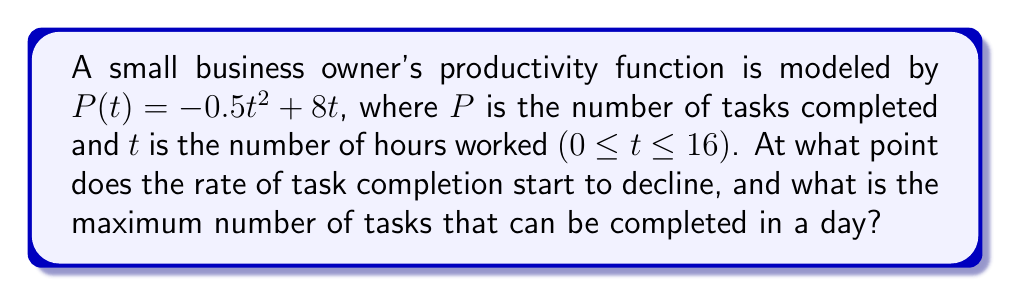Can you solve this math problem? 1. To find when the rate of task completion starts to decline, we need to find the maximum point of the productivity function. This occurs when the derivative of $P(t)$ equals zero.

2. Find the derivative of $P(t)$:
   $P'(t) = \frac{d}{dt}(-0.5t^2 + 8t) = -t + 8$

3. Set $P'(t) = 0$ and solve for $t$:
   $-t + 8 = 0$
   $t = 8$

4. This means the rate of task completion starts to decline after 8 hours of work.

5. To find the maximum number of tasks completed, substitute $t = 8$ into the original function:
   $P(8) = -0.5(8)^2 + 8(8) = -32 + 64 = 32$

Therefore, the maximum number of tasks that can be completed in a day is 32.
Answer: Rate declines after 8 hours; maximum 32 tasks per day 